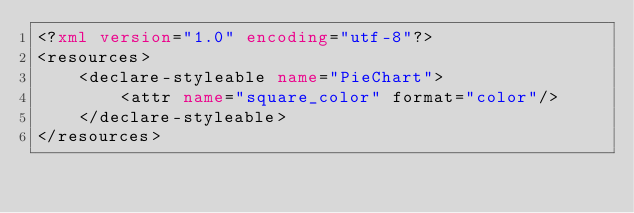Convert code to text. <code><loc_0><loc_0><loc_500><loc_500><_XML_><?xml version="1.0" encoding="utf-8"?>
<resources>
    <declare-styleable name="PieChart">
        <attr name="square_color" format="color"/>
    </declare-styleable>
</resources></code> 